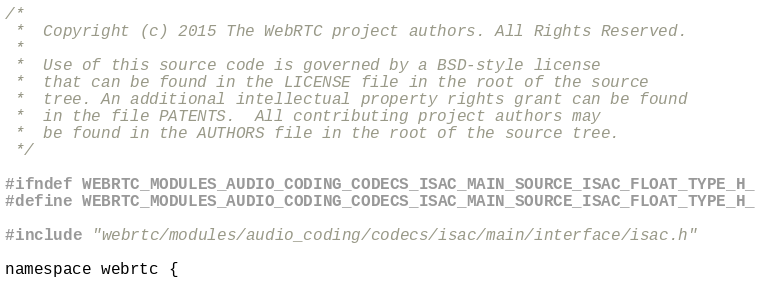<code> <loc_0><loc_0><loc_500><loc_500><_C_>/*
 *  Copyright (c) 2015 The WebRTC project authors. All Rights Reserved.
 *
 *  Use of this source code is governed by a BSD-style license
 *  that can be found in the LICENSE file in the root of the source
 *  tree. An additional intellectual property rights grant can be found
 *  in the file PATENTS.  All contributing project authors may
 *  be found in the AUTHORS file in the root of the source tree.
 */

#ifndef WEBRTC_MODULES_AUDIO_CODING_CODECS_ISAC_MAIN_SOURCE_ISAC_FLOAT_TYPE_H_
#define WEBRTC_MODULES_AUDIO_CODING_CODECS_ISAC_MAIN_SOURCE_ISAC_FLOAT_TYPE_H_

#include "webrtc/modules/audio_coding/codecs/isac/main/interface/isac.h"

namespace webrtc {
</code> 